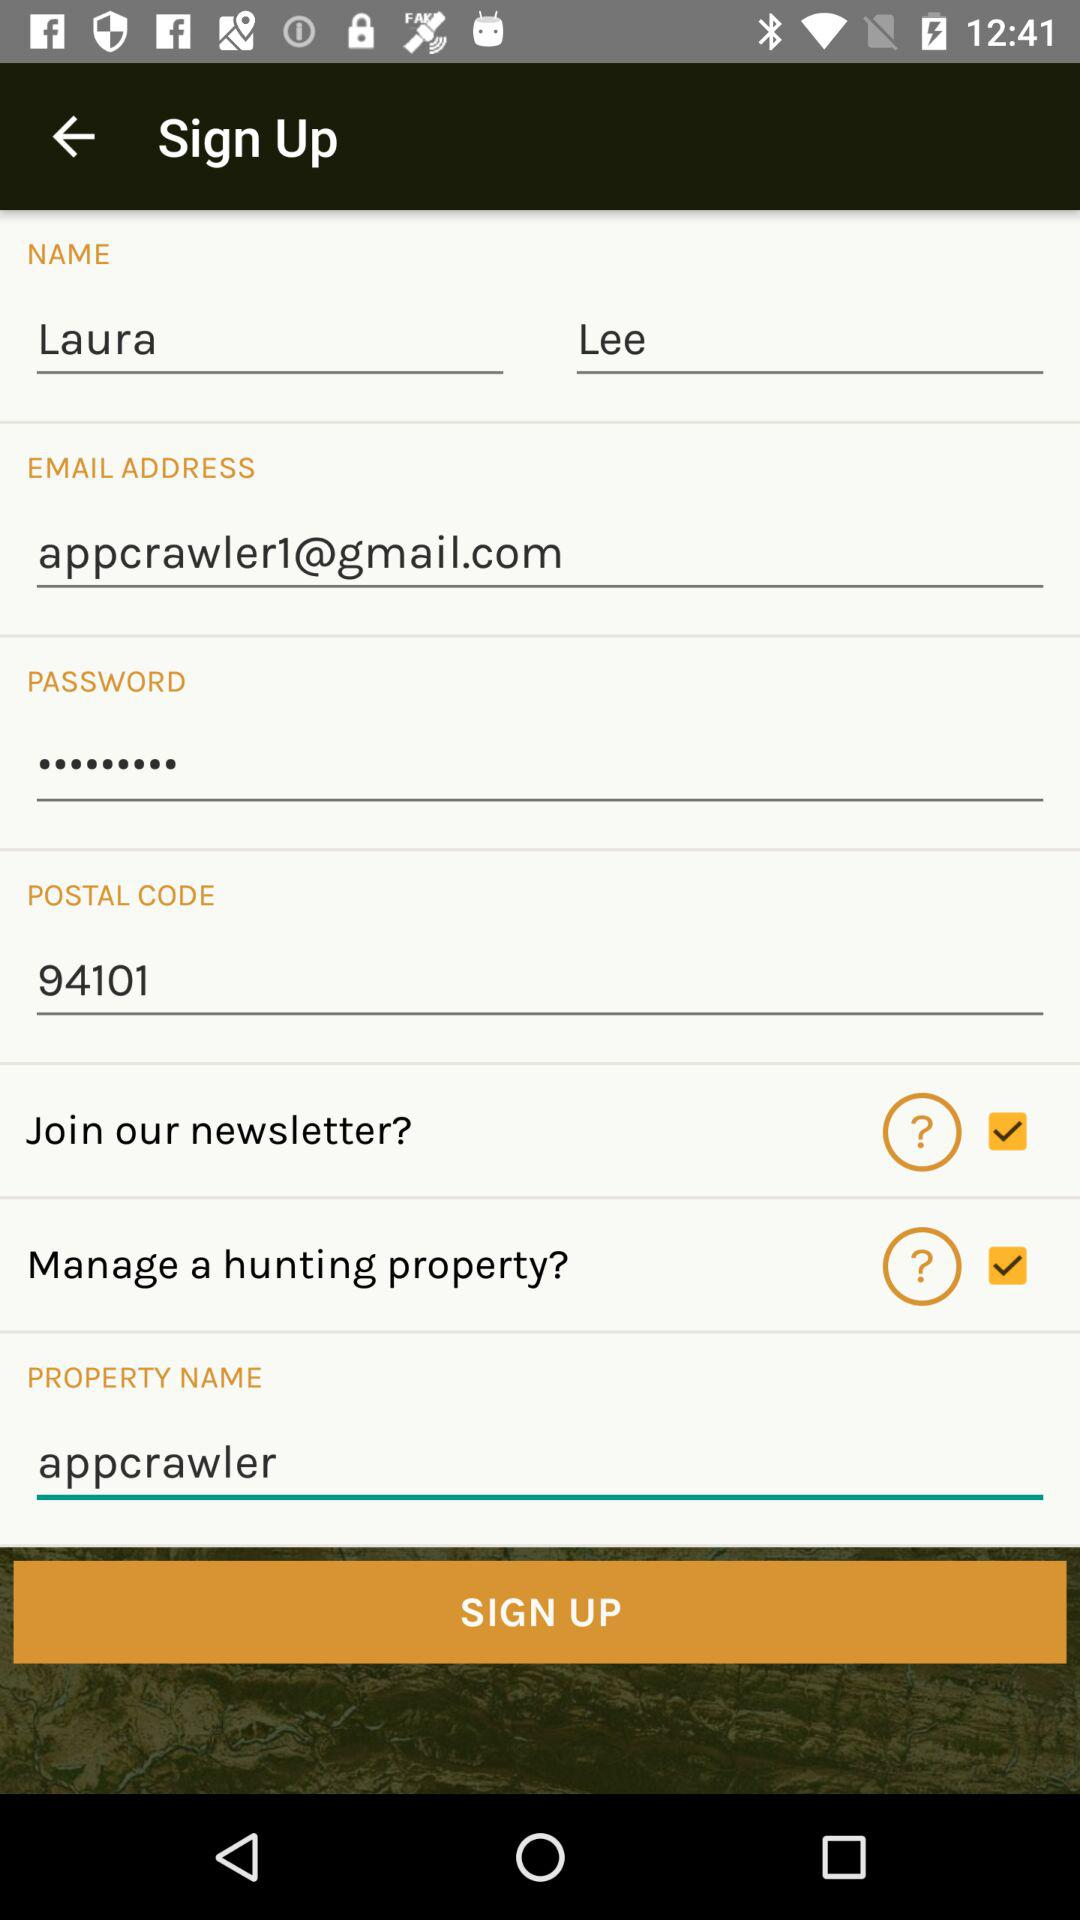How many characters are required to create a password?
When the provided information is insufficient, respond with <no answer>. <no answer> 